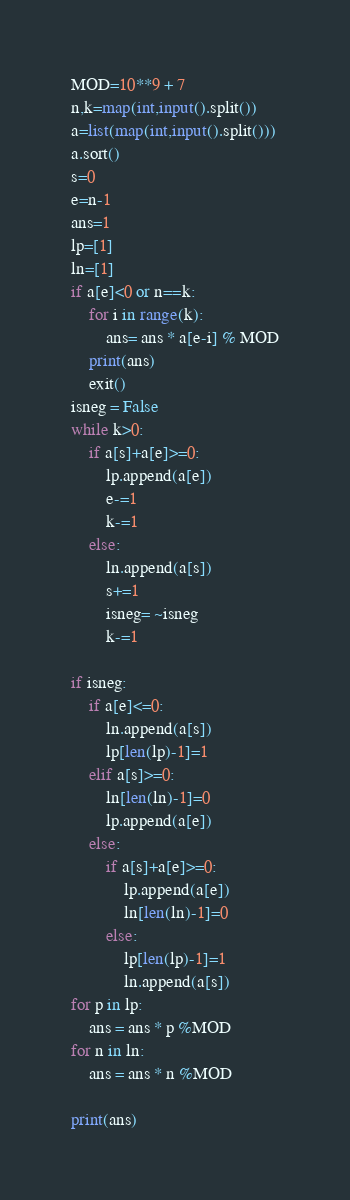Convert code to text. <code><loc_0><loc_0><loc_500><loc_500><_Python_>MOD=10**9 + 7
n,k=map(int,input().split())
a=list(map(int,input().split()))
a.sort()
s=0
e=n-1
ans=1
lp=[1]
ln=[1]
if a[e]<0 or n==k:
    for i in range(k):
        ans= ans * a[e-i] % MOD
    print(ans)
    exit()
isneg = False
while k>0:
    if a[s]+a[e]>=0:
        lp.append(a[e])
        e-=1
        k-=1
    else:
        ln.append(a[s])
        s+=1
        isneg= ~isneg
        k-=1

if isneg:
    if a[e]<=0:
        ln.append(a[s])
        lp[len(lp)-1]=1
    elif a[s]>=0:
        ln[len(ln)-1]=0
        lp.append(a[e])
    else:
        if a[s]+a[e]>=0:
            lp.append(a[e])
            ln[len(ln)-1]=0
        else:
            lp[len(lp)-1]=1
            ln.append(a[s])
for p in lp:
    ans = ans * p %MOD
for n in ln:
    ans = ans * n %MOD

print(ans)</code> 